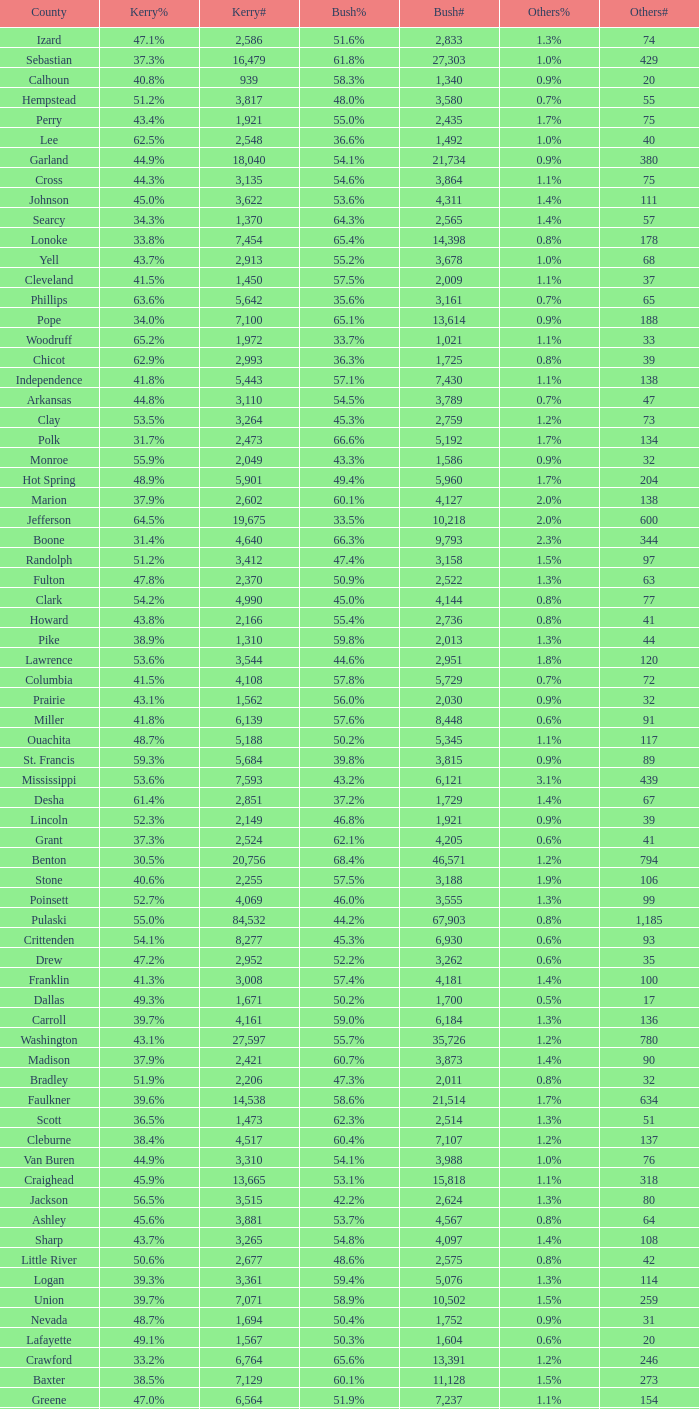What is the highest Bush#, when Others% is "1.7%", when Others# is less than 75, and when Kerry# is greater than 1,524? None. 